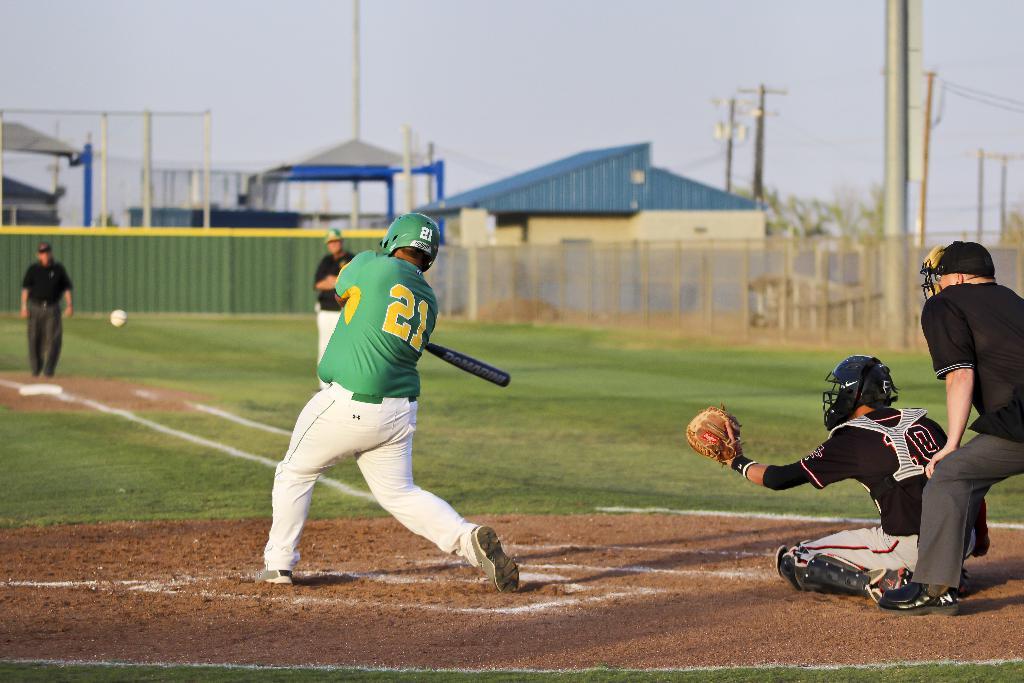What is this player's number?
Provide a succinct answer. 21. Is the players number also on his helmet?
Ensure brevity in your answer.  Yes. 